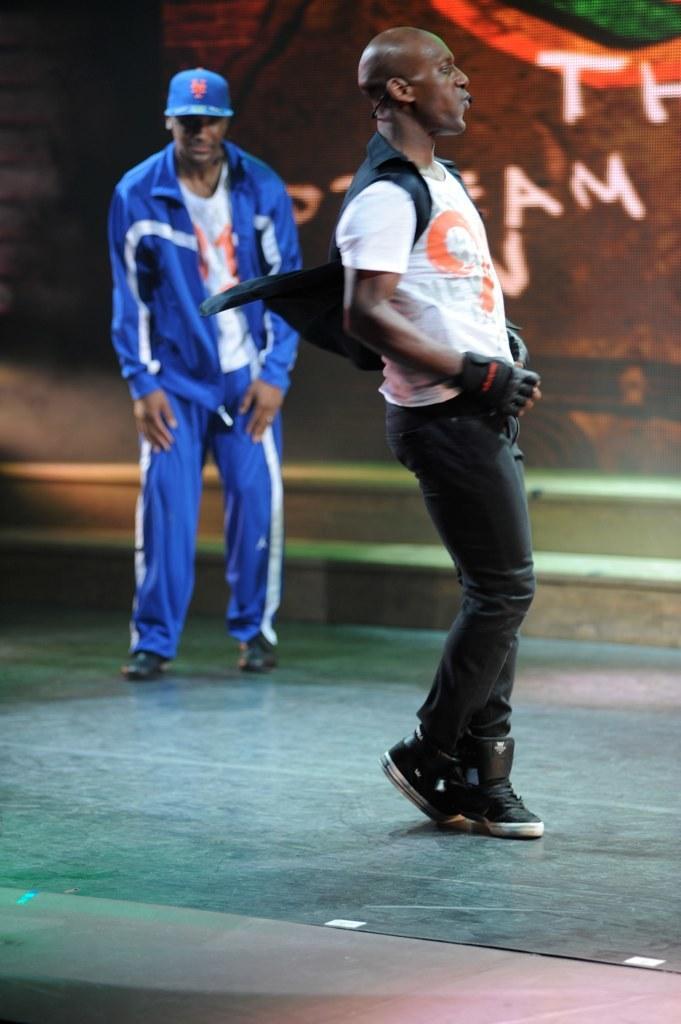How would you summarize this image in a sentence or two? In this image there is a man dancing on the floor. Behind him there is another man standing. In the background there is a wall. There is text on the wall. There are steps near to the wall. 